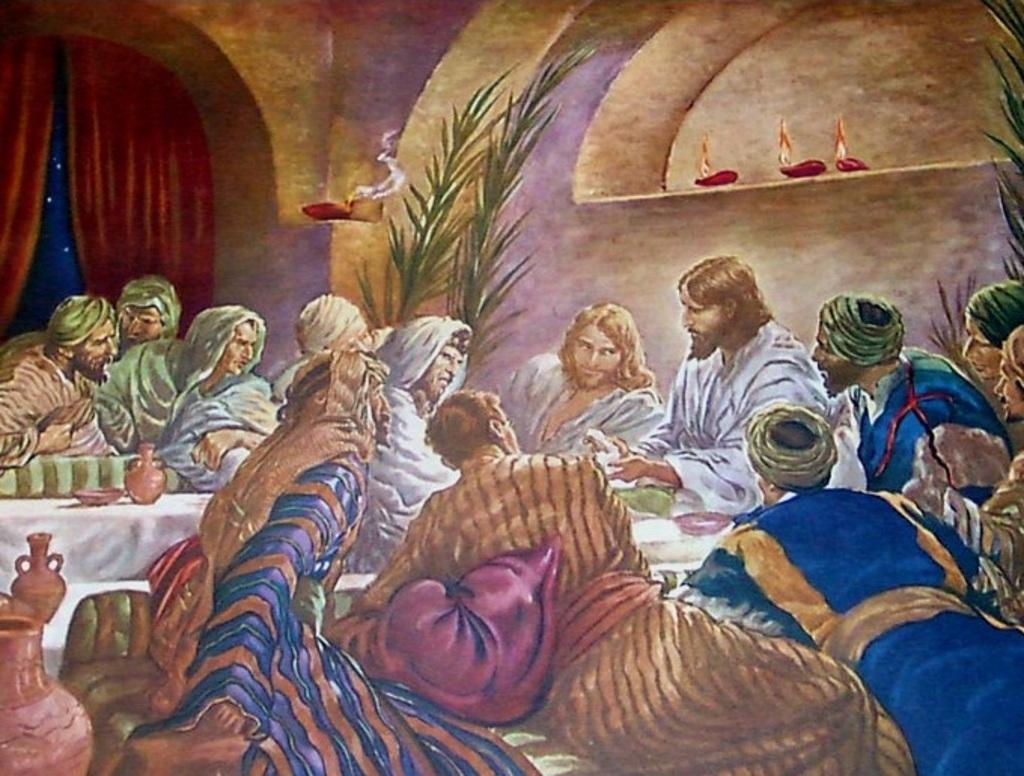What are the people in the image doing? There is a group of people sitting in the image. What type of containers can be seen in the image? There are pots and a bowl in the image. What is the purpose of the lighted objects in the image? Lighted diyas are present in the image, which might be used for lighting or decoration. What type of vegetation is visible in the image? There are plants in the image. What is the background of the image made of? There is a wall in the image, and curtains are also present. Can you describe any other objects in the image? There are some unspecified objects in the image. What books are the people reading in the image? There is no mention of books in the image; the people are sitting, and other objects are present, but no books are visible. 